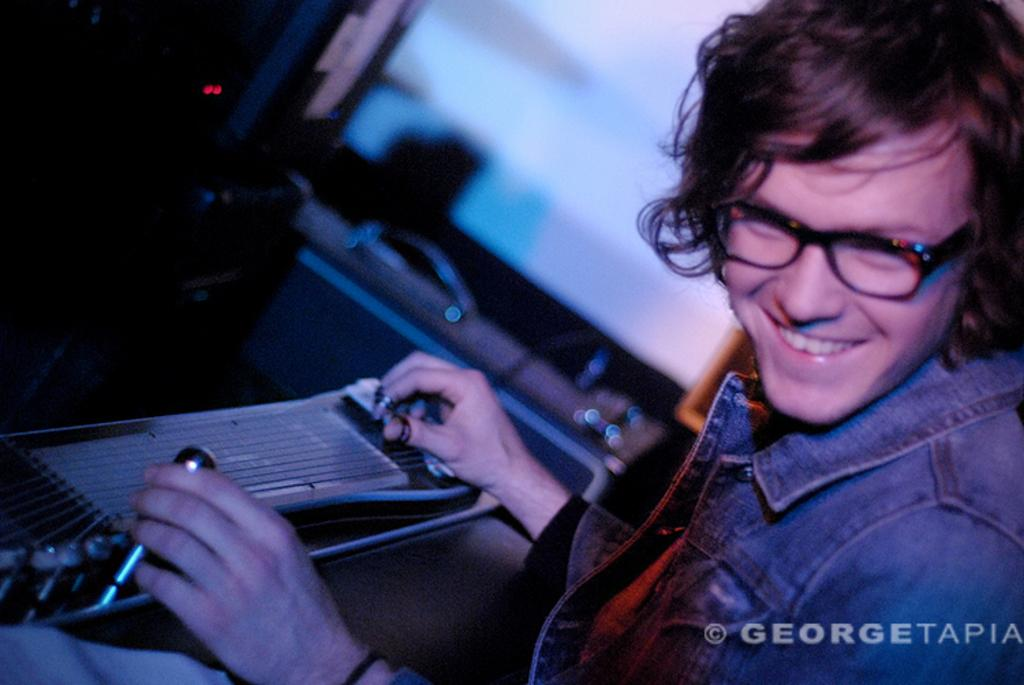What is the main subject of the image? There is a person in the image. What is the person doing in the image? The person is holding something and smiling. What can be observed about the background of the image? The background of the image is dark in color. What level of force is the person applying to the object they are holding in the image? There is no information provided about the level of force the person is applying to the object they are holding in the image. --- Facts: 1. There is a car in the image. 2. The car is red. 3. The car has four wheels. 4. The car has a license plate. 5. The car is parked on the street. Absurd Topics: bird, ocean, mountain Conversation: What is the main subject of the image? There is a car in the image. What color is the car? The car is red. How many wheels does the car have? The car has four wheels. Does the car have any identifying features? Yes, the car has a license plate. Where is the car located in the image? The car is parked on the street. Reasoning: Let's think step by step in order to produce the conversation. We start by identifying the main subject of the image, which is the car. Then, we describe the car's color, number of wheels, and the presence of a license plate. Finally, we describe the car's location, which is parked on the street. Absurd Question/Answer: Can you see any birds flying over the ocean or mountain in the image? There is no mention of birds, ocean, or mountain in the image; it features a red car parked on the street. 